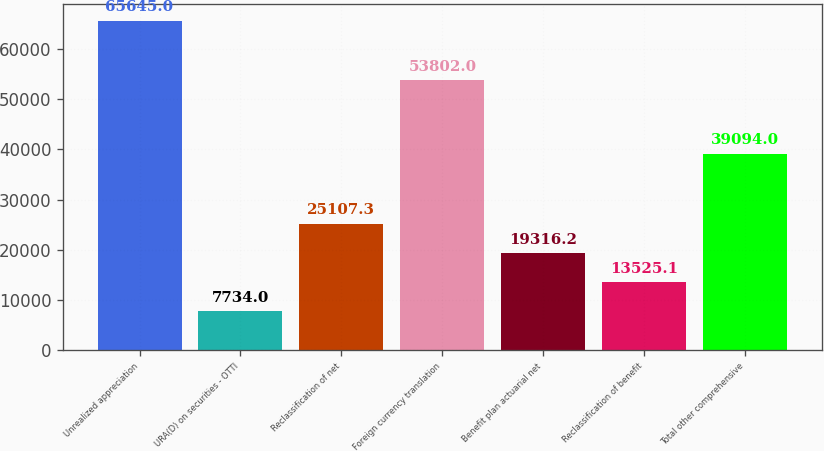Convert chart. <chart><loc_0><loc_0><loc_500><loc_500><bar_chart><fcel>Unrealized appreciation<fcel>URA(D) on securities - OTTI<fcel>Reclassification of net<fcel>Foreign currency translation<fcel>Benefit plan actuarial net<fcel>Reclassification of benefit<fcel>Total other comprehensive<nl><fcel>65645<fcel>7734<fcel>25107.3<fcel>53802<fcel>19316.2<fcel>13525.1<fcel>39094<nl></chart> 